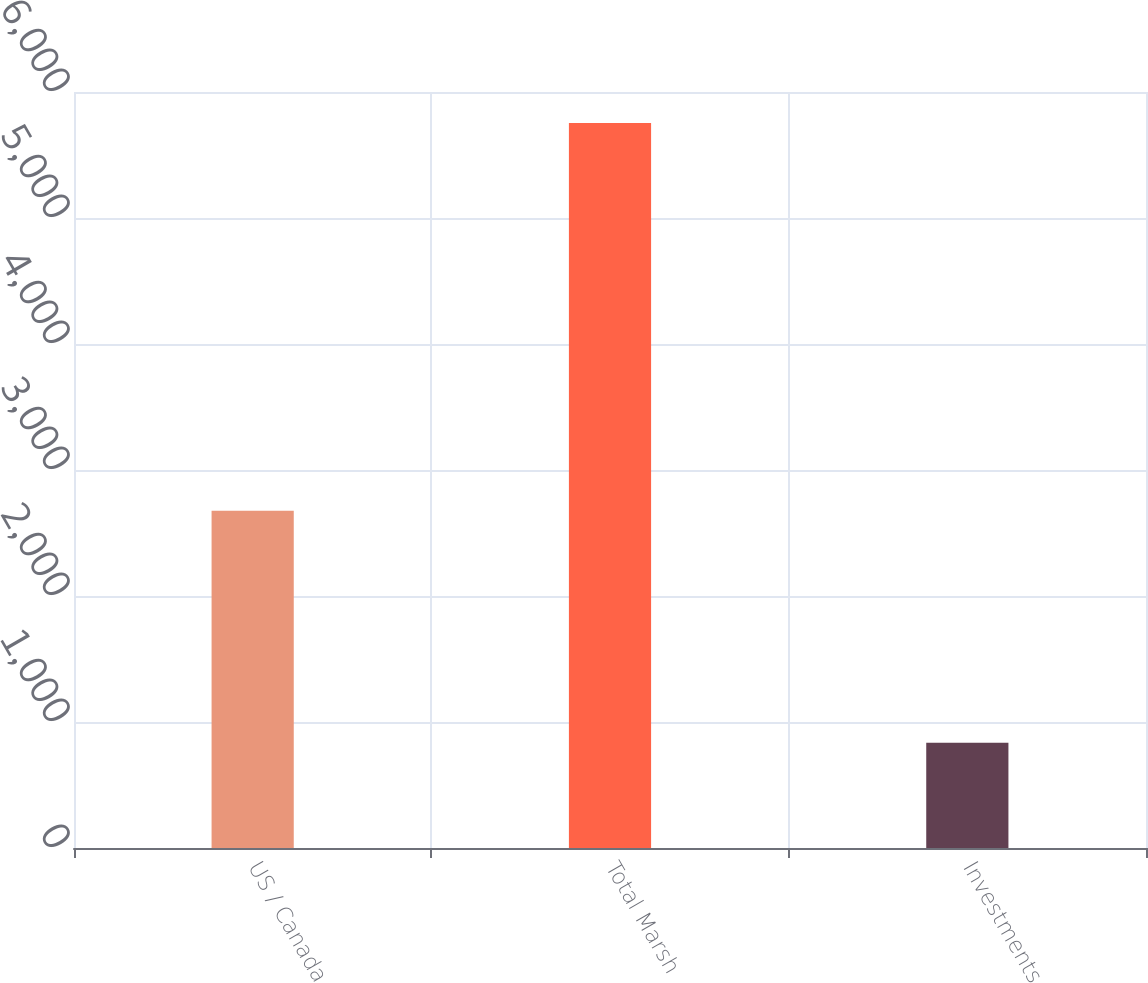Convert chart to OTSL. <chart><loc_0><loc_0><loc_500><loc_500><bar_chart><fcel>US / Canada<fcel>Total Marsh<fcel>Investments<nl><fcel>2677<fcel>5753<fcel>836<nl></chart> 